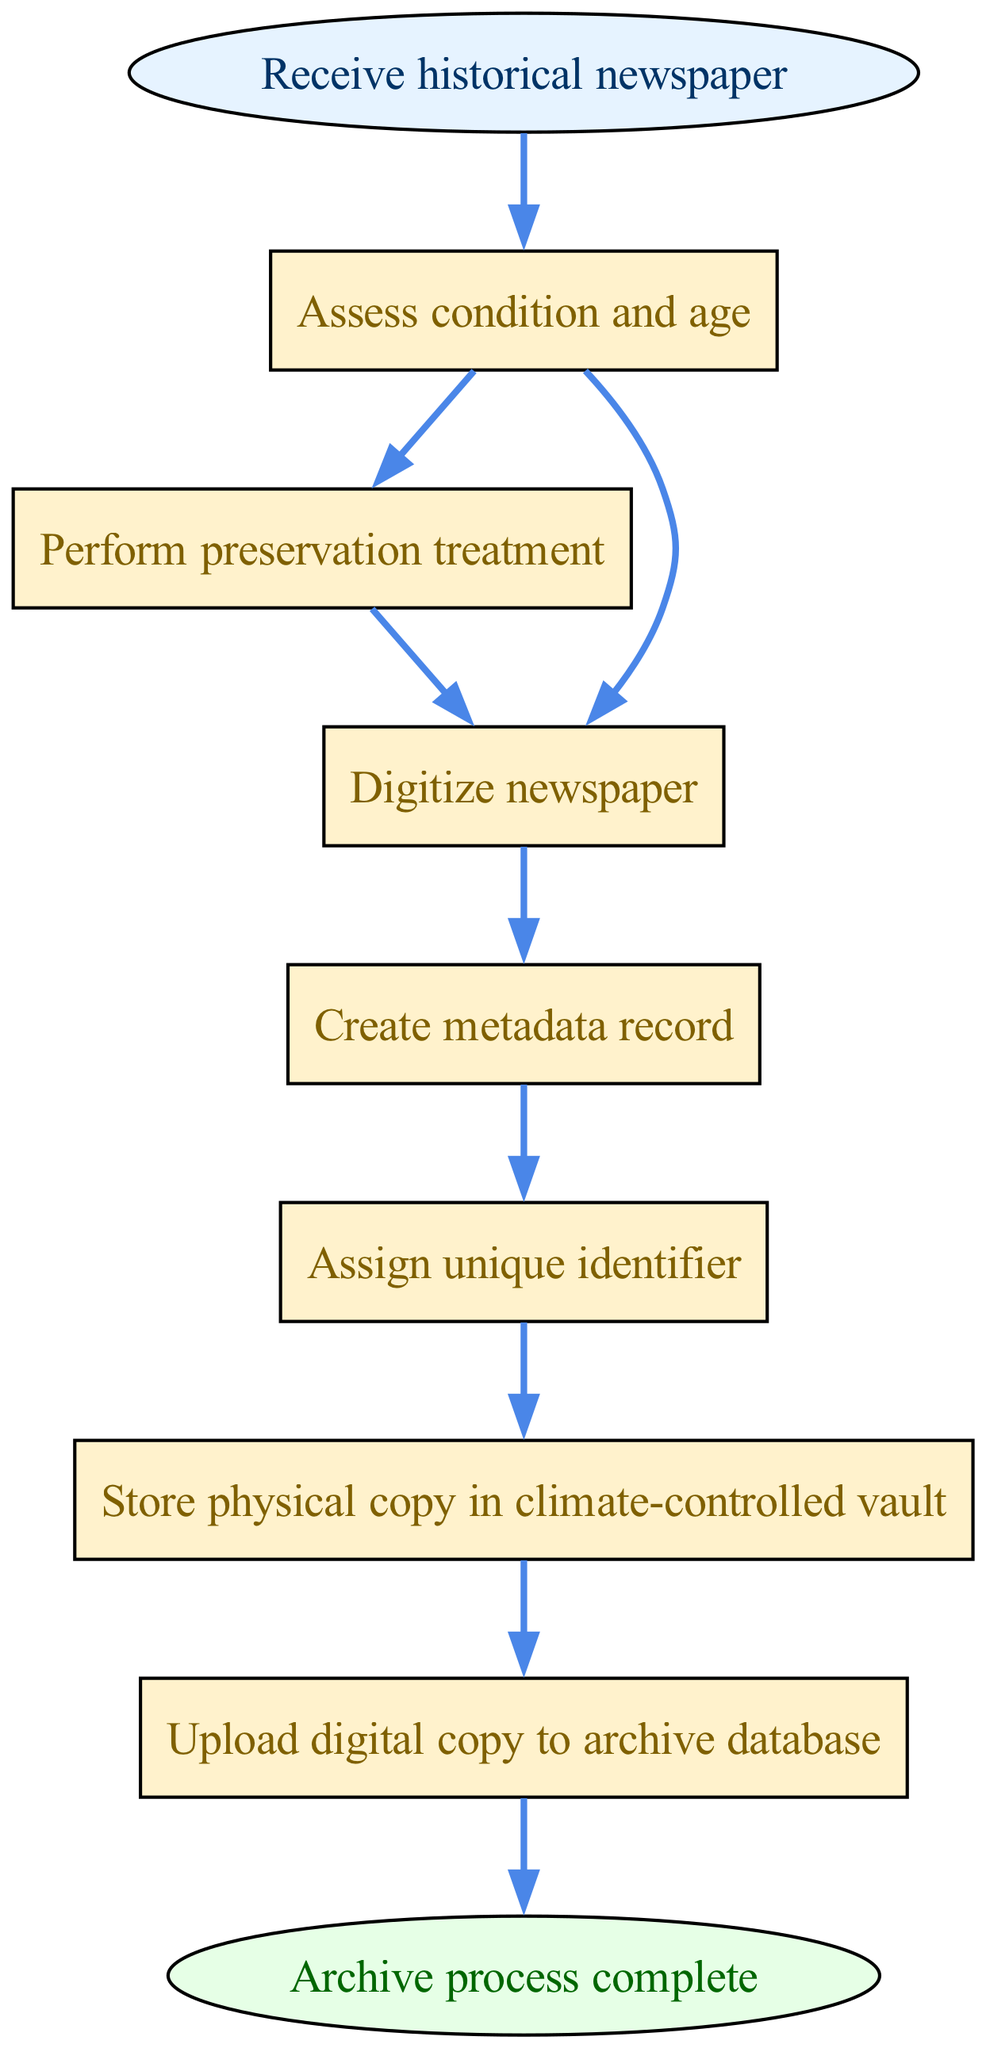What is the first step in the process? The first step in the diagram is "Receive historical newspaper," which is indicated as the start node.
Answer: Receive historical newspaper How many nodes are there in the diagram? The total number of nodes is counted by including the start node, all the process nodes, and the end node. There are 7 process nodes, 1 start node, and 1 end node, totaling to 9 nodes.
Answer: 9 What is the last step before archiving is complete? The step preceding the end node is "Upload digital copy to archive database," indicating the last action before completing the process.
Answer: Upload digital copy to archive database What step follows the "Perform preservation treatment"? The step that follows "Perform preservation treatment" is "Digitize newspaper," as indicated by the directed edge leading from node 2 to node 3.
Answer: Digitize newspaper How many steps involve creating or managing digital copies? There are two steps that involve creating or managing digital copies: "Digitize newspaper" and "Upload digital copy to archive database."
Answer: 2 Which step involves identifying the newspaper uniquely? The step where the unique identification occurs is "Assign unique identifier," highlighted in node 5 of the diagram as crucial for cataloging.
Answer: Assign unique identifier What is the flow from assessing the condition? The flow from "Assess condition and age" leads to two options: it can either proceed to "Perform preservation treatment" or directly to "Digitize newspaper," indicating a branching process based on the assessment.
Answer: Perform preservation treatment or Digitize newspaper What is required before storing the physical copy? Before storing the physical copy, the preservation treatment must be performed, as indicated by the flow from "Assess condition and age" to "Perform preservation treatment."
Answer: Perform preservation treatment What color represents the process nodes? The process nodes are represented in a yellowish color, specifically filled with a hex color code corresponding to a light yellow shade, which is "#FFF2CC" in the diagram.
Answer: Yellow 